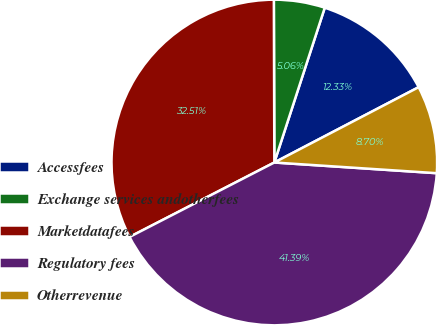Convert chart. <chart><loc_0><loc_0><loc_500><loc_500><pie_chart><fcel>Accessfees<fcel>Exchange services andotherfees<fcel>Marketdatafees<fcel>Regulatory fees<fcel>Otherrevenue<nl><fcel>12.33%<fcel>5.06%<fcel>32.51%<fcel>41.39%<fcel>8.7%<nl></chart> 